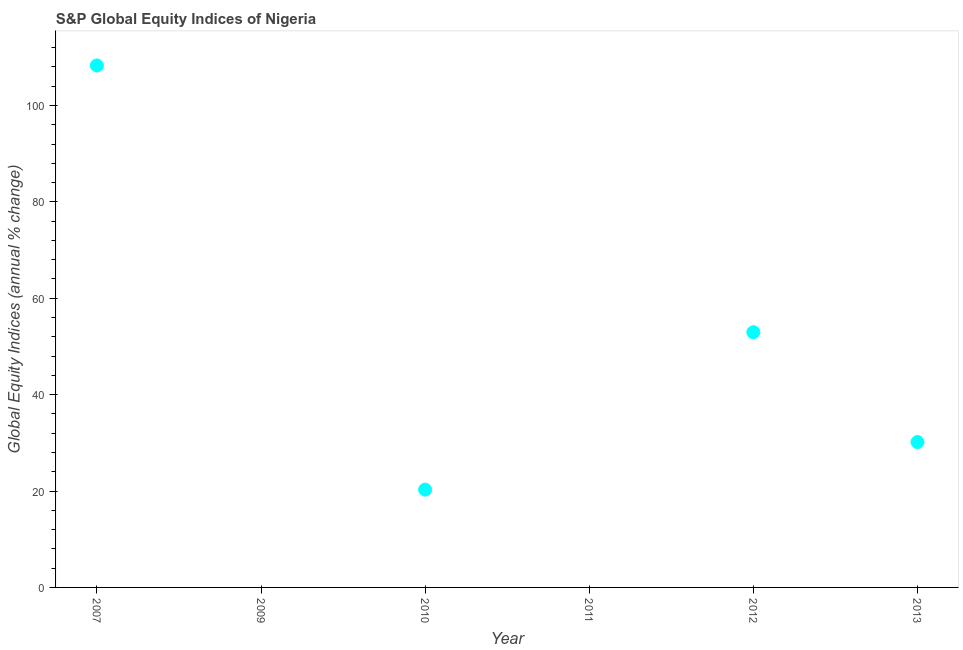What is the s&p global equity indices in 2010?
Keep it short and to the point. 20.29. Across all years, what is the maximum s&p global equity indices?
Give a very brief answer. 108.3. What is the sum of the s&p global equity indices?
Your response must be concise. 211.71. What is the difference between the s&p global equity indices in 2007 and 2012?
Offer a very short reply. 55.35. What is the average s&p global equity indices per year?
Your answer should be very brief. 35.28. What is the median s&p global equity indices?
Offer a terse response. 25.23. What is the ratio of the s&p global equity indices in 2007 to that in 2012?
Your response must be concise. 2.05. Is the difference between the s&p global equity indices in 2007 and 2012 greater than the difference between any two years?
Give a very brief answer. No. What is the difference between the highest and the second highest s&p global equity indices?
Make the answer very short. 55.35. Is the sum of the s&p global equity indices in 2010 and 2012 greater than the maximum s&p global equity indices across all years?
Provide a succinct answer. No. What is the difference between the highest and the lowest s&p global equity indices?
Provide a short and direct response. 108.3. In how many years, is the s&p global equity indices greater than the average s&p global equity indices taken over all years?
Your response must be concise. 2. How many dotlines are there?
Your response must be concise. 1. How many years are there in the graph?
Your answer should be compact. 6. Are the values on the major ticks of Y-axis written in scientific E-notation?
Offer a very short reply. No. Does the graph contain any zero values?
Offer a terse response. Yes. Does the graph contain grids?
Provide a short and direct response. No. What is the title of the graph?
Give a very brief answer. S&P Global Equity Indices of Nigeria. What is the label or title of the X-axis?
Your answer should be very brief. Year. What is the label or title of the Y-axis?
Make the answer very short. Global Equity Indices (annual % change). What is the Global Equity Indices (annual % change) in 2007?
Your answer should be very brief. 108.3. What is the Global Equity Indices (annual % change) in 2010?
Provide a short and direct response. 20.29. What is the Global Equity Indices (annual % change) in 2012?
Ensure brevity in your answer.  52.95. What is the Global Equity Indices (annual % change) in 2013?
Your answer should be very brief. 30.16. What is the difference between the Global Equity Indices (annual % change) in 2007 and 2010?
Provide a succinct answer. 88.01. What is the difference between the Global Equity Indices (annual % change) in 2007 and 2012?
Provide a succinct answer. 55.35. What is the difference between the Global Equity Indices (annual % change) in 2007 and 2013?
Provide a short and direct response. 78.14. What is the difference between the Global Equity Indices (annual % change) in 2010 and 2012?
Provide a short and direct response. -32.66. What is the difference between the Global Equity Indices (annual % change) in 2010 and 2013?
Your answer should be compact. -9.87. What is the difference between the Global Equity Indices (annual % change) in 2012 and 2013?
Your response must be concise. 22.79. What is the ratio of the Global Equity Indices (annual % change) in 2007 to that in 2010?
Provide a short and direct response. 5.34. What is the ratio of the Global Equity Indices (annual % change) in 2007 to that in 2012?
Ensure brevity in your answer.  2.04. What is the ratio of the Global Equity Indices (annual % change) in 2007 to that in 2013?
Your response must be concise. 3.59. What is the ratio of the Global Equity Indices (annual % change) in 2010 to that in 2012?
Provide a short and direct response. 0.38. What is the ratio of the Global Equity Indices (annual % change) in 2010 to that in 2013?
Ensure brevity in your answer.  0.67. What is the ratio of the Global Equity Indices (annual % change) in 2012 to that in 2013?
Your response must be concise. 1.75. 